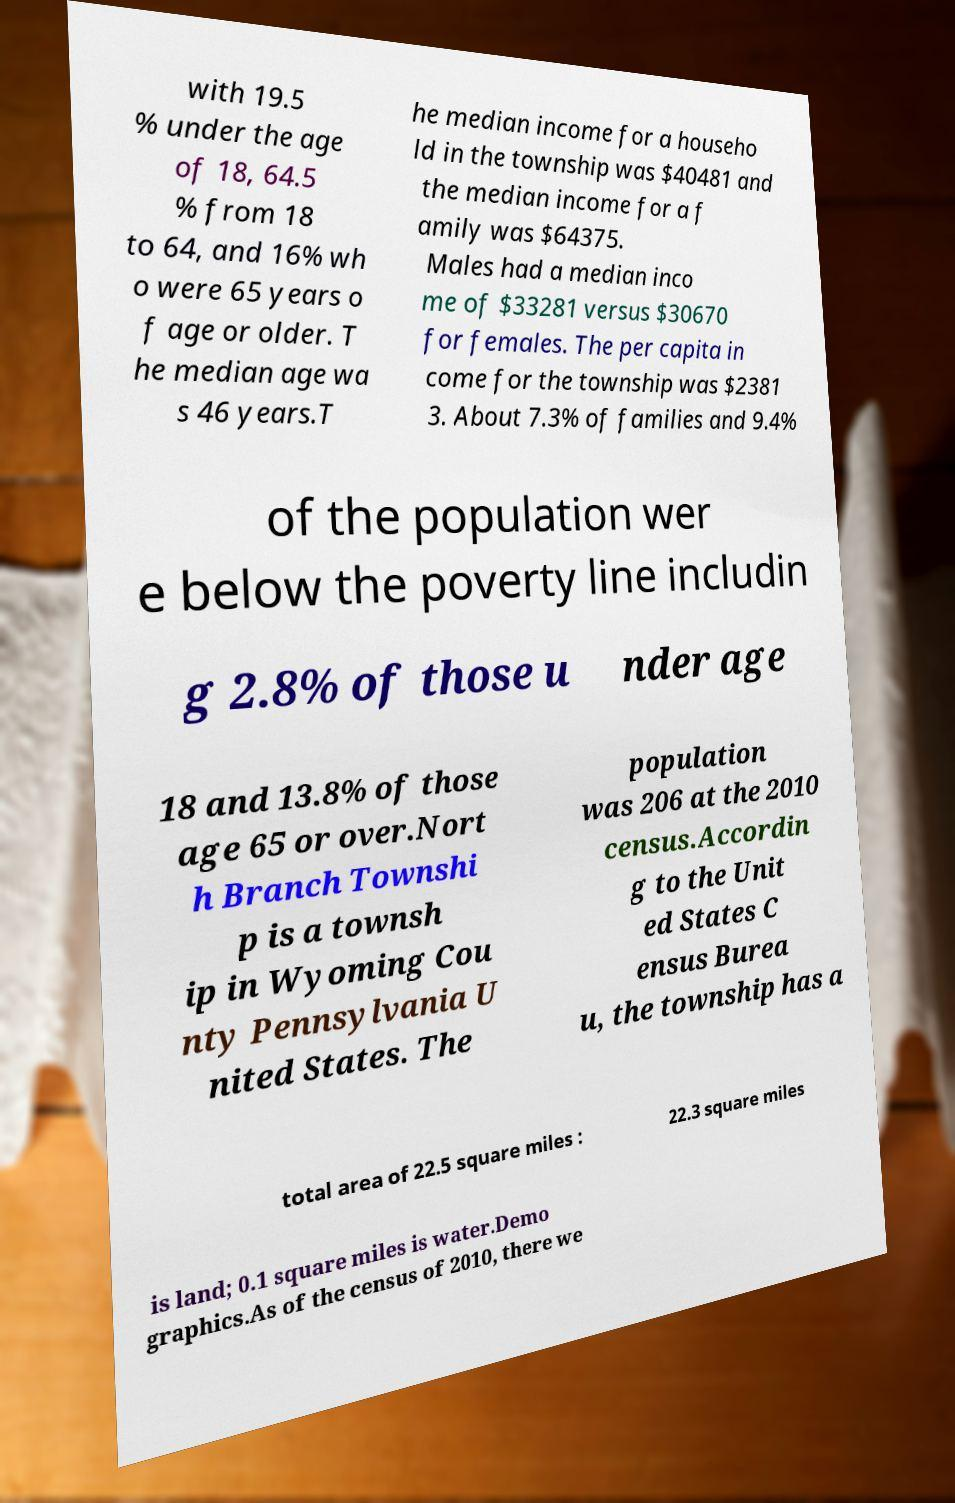Can you accurately transcribe the text from the provided image for me? with 19.5 % under the age of 18, 64.5 % from 18 to 64, and 16% wh o were 65 years o f age or older. T he median age wa s 46 years.T he median income for a househo ld in the township was $40481 and the median income for a f amily was $64375. Males had a median inco me of $33281 versus $30670 for females. The per capita in come for the township was $2381 3. About 7.3% of families and 9.4% of the population wer e below the poverty line includin g 2.8% of those u nder age 18 and 13.8% of those age 65 or over.Nort h Branch Townshi p is a townsh ip in Wyoming Cou nty Pennsylvania U nited States. The population was 206 at the 2010 census.Accordin g to the Unit ed States C ensus Burea u, the township has a total area of 22.5 square miles : 22.3 square miles is land; 0.1 square miles is water.Demo graphics.As of the census of 2010, there we 